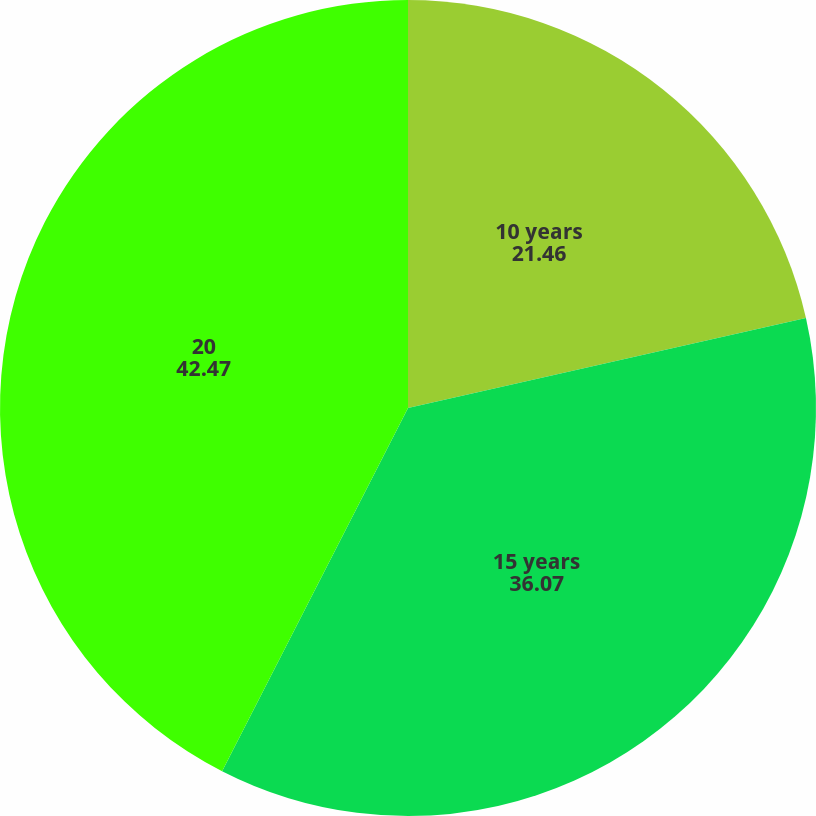Convert chart. <chart><loc_0><loc_0><loc_500><loc_500><pie_chart><fcel>10 years<fcel>15 years<fcel>20<nl><fcel>21.46%<fcel>36.07%<fcel>42.47%<nl></chart> 